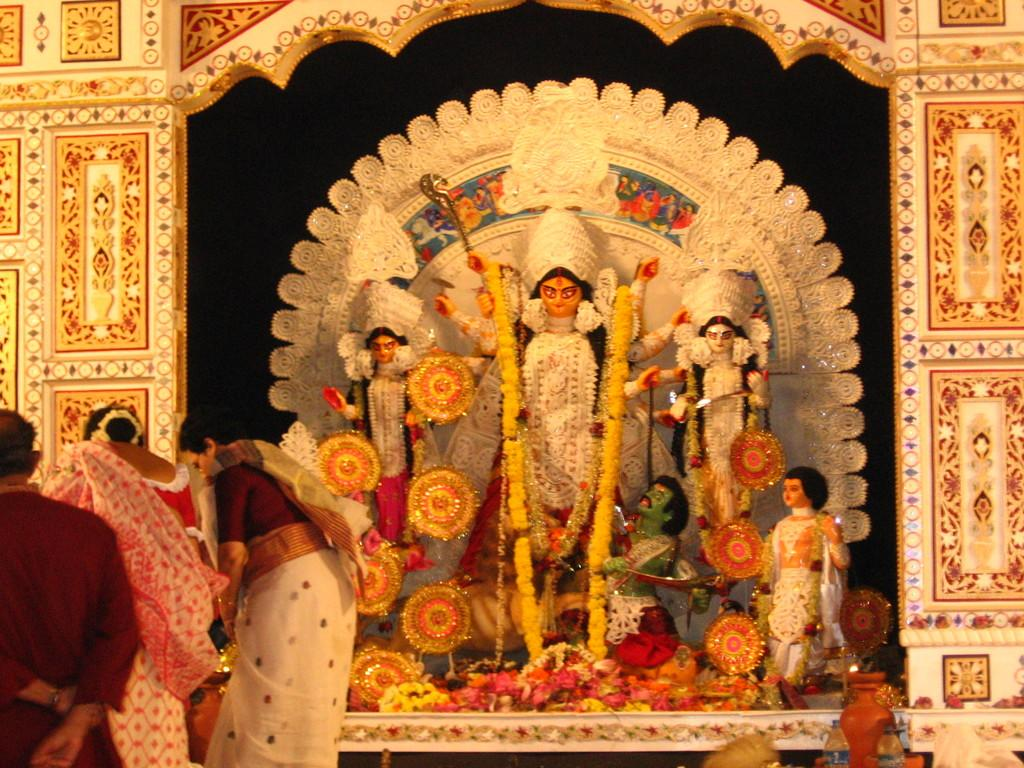What type of objects can be seen in the image? There are statues in the image. What decorative element is present in the image? There is a garland in the image. What type of natural elements are in the image? There are flowers in the image. Are there any living beings in the image? Yes, there are people in the image. What type of architectural feature is visible in the image? There is a wall in the image. What type of leather material can be seen on the statues in the image? There is no leather material present on the statues in the image. What caption is written on the garland in the image? There is no caption written on the garland in the image; it is a decorative element made of flowers or other materials. 